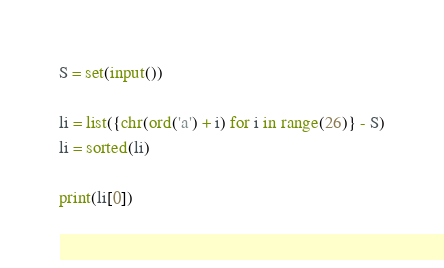<code> <loc_0><loc_0><loc_500><loc_500><_Python_>S = set(input())

li = list({chr(ord('a') + i) for i in range(26)} - S)
li = sorted(li)

print(li[0])</code> 